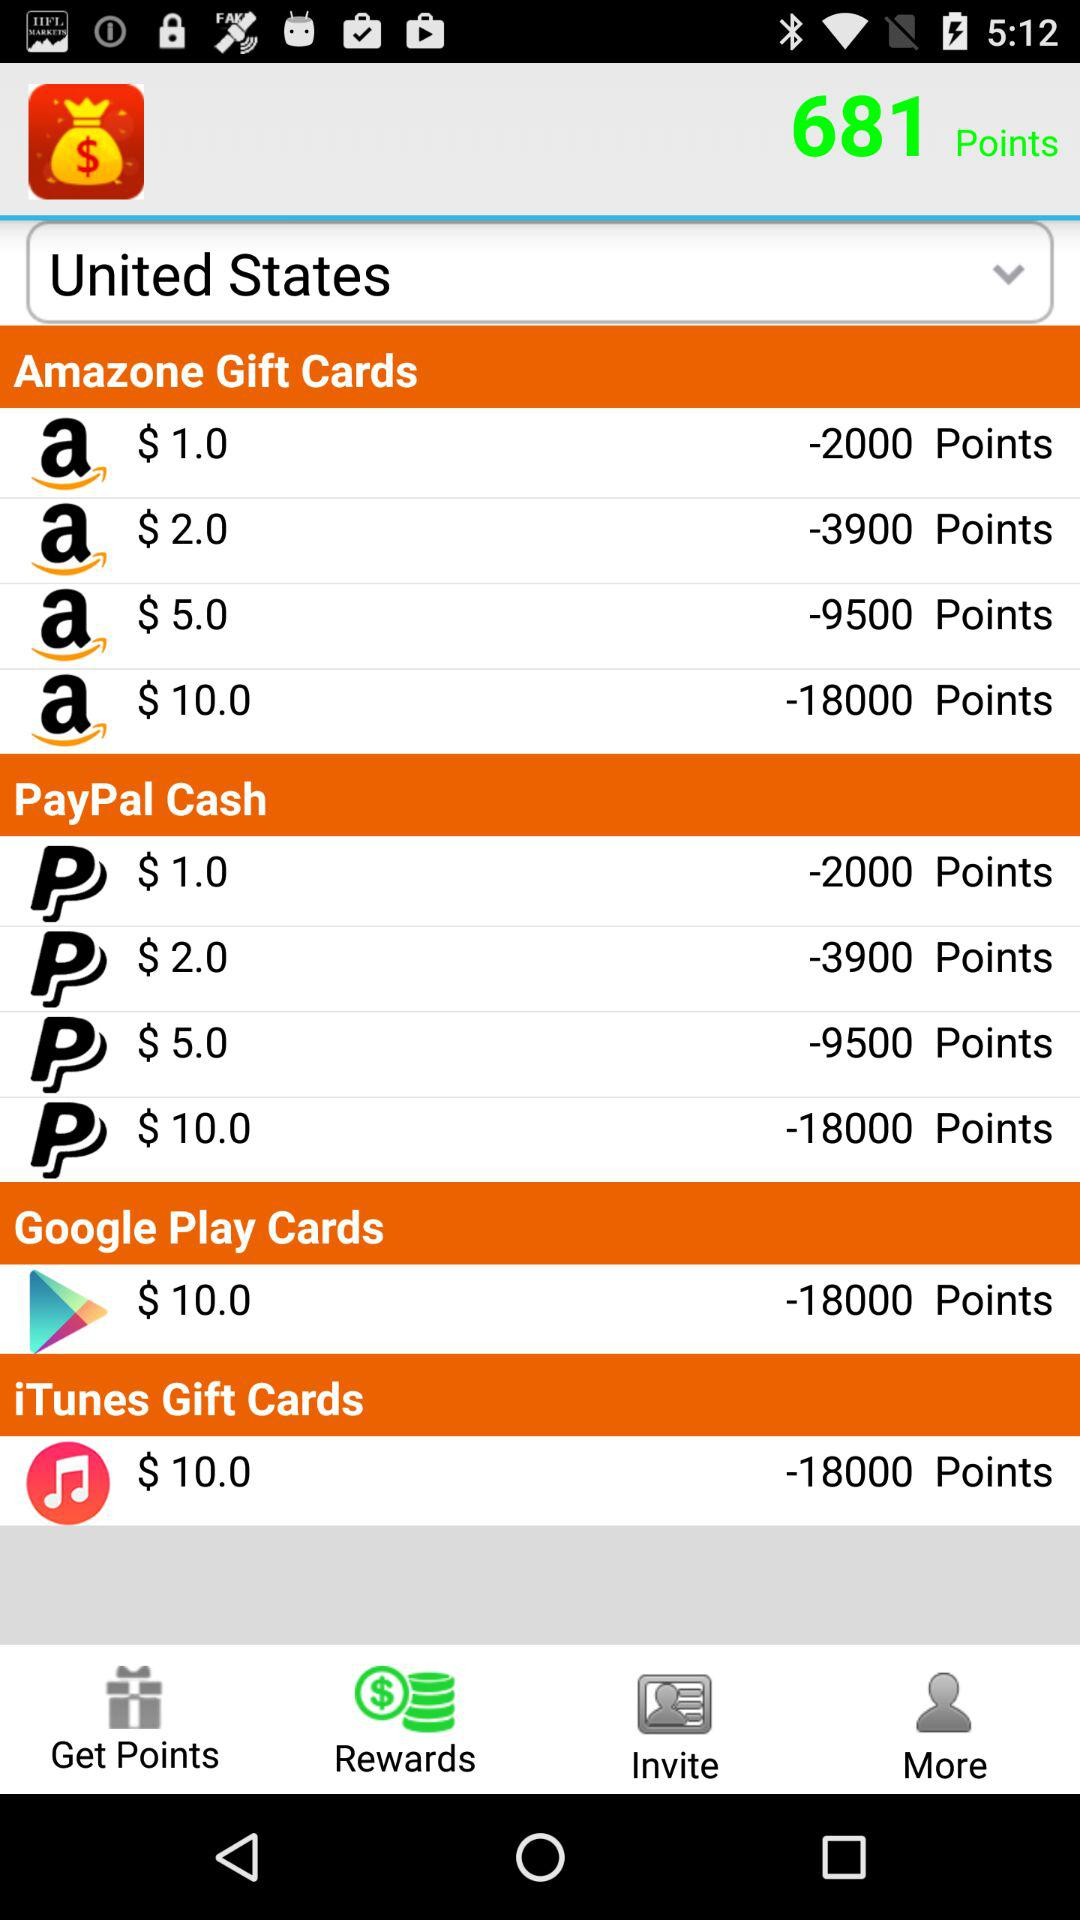Which country has been selected? The country that has been selected is the United States. 